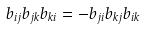<formula> <loc_0><loc_0><loc_500><loc_500>b _ { i j } b _ { j k } b _ { k i } = - b _ { j i } b _ { k j } b _ { i k }</formula> 